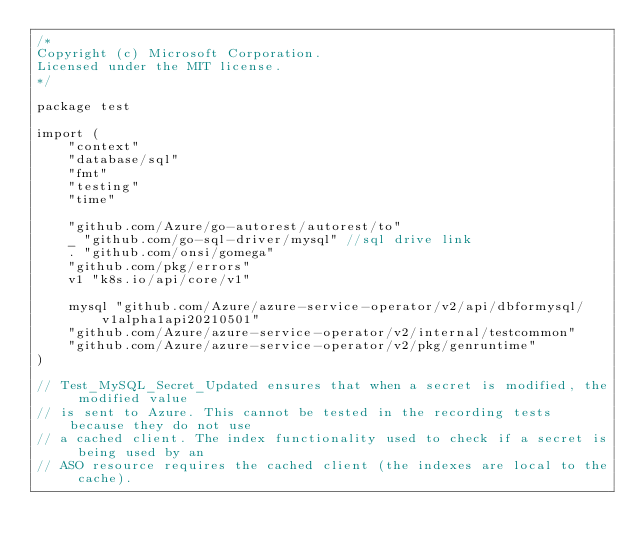Convert code to text. <code><loc_0><loc_0><loc_500><loc_500><_Go_>/*
Copyright (c) Microsoft Corporation.
Licensed under the MIT license.
*/

package test

import (
	"context"
	"database/sql"
	"fmt"
	"testing"
	"time"

	"github.com/Azure/go-autorest/autorest/to"
	_ "github.com/go-sql-driver/mysql" //sql drive link
	. "github.com/onsi/gomega"
	"github.com/pkg/errors"
	v1 "k8s.io/api/core/v1"

	mysql "github.com/Azure/azure-service-operator/v2/api/dbformysql/v1alpha1api20210501"
	"github.com/Azure/azure-service-operator/v2/internal/testcommon"
	"github.com/Azure/azure-service-operator/v2/pkg/genruntime"
)

// Test_MySQL_Secret_Updated ensures that when a secret is modified, the modified value
// is sent to Azure. This cannot be tested in the recording tests because they do not use
// a cached client. The index functionality used to check if a secret is being used by an
// ASO resource requires the cached client (the indexes are local to the cache).</code> 